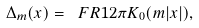<formula> <loc_0><loc_0><loc_500><loc_500>\Delta _ { m } ( x ) = \ F R 1 { 2 \pi } K _ { 0 } ( m | x | ) ,</formula> 